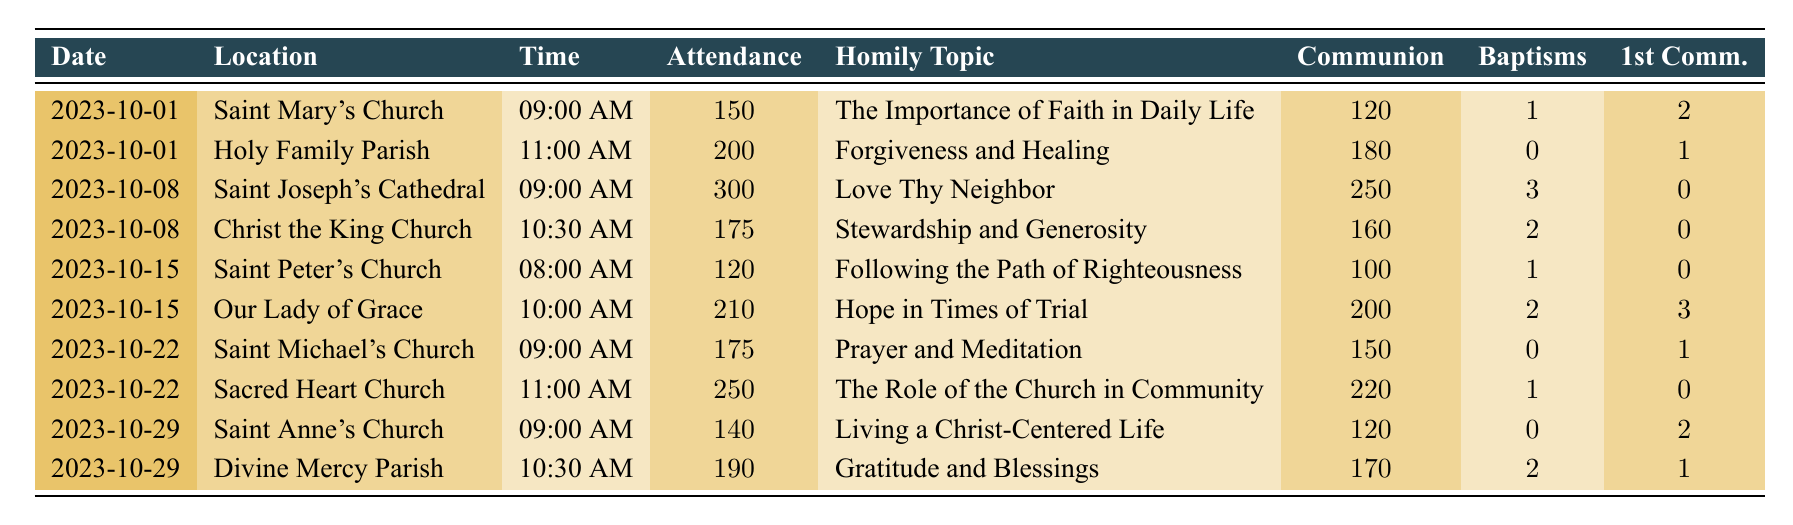What was the highest attendance recorded in a single week during October 2023? By examining the attendance column in the table, the highest attendance is found on the date 2023-10-08 at Saint Joseph's Cathedral, where 300 people attended.
Answer: 300 How many baptisms occurred across all services on October 15, 2023? Summing the baptisms from both services on that date: 1 from Saint Peter's Church and 2 from Our Lady of Grace gives a total of 1 + 2 = 3 baptisms.
Answer: 3 Which church had the topic "Hope in Times of Trial"? Looking for the specific homily topic in the table, it is found in Our Lady of Grace on October 15, 2023.
Answer: Our Lady of Grace Did any service on October 22, 2023, have more than 200 attendees? Reviewing the attendance for that date shows Sacred Heart Church had 250 attendees, so yes, it had more than 200 attendees.
Answer: Yes What is the average attendance across all services for the week of October 1, 2023? Calculate the total attendance for that week: 150 (Saint Mary's) + 200 (Holy Family) = 350. Divide by the number of services (2): 350 / 2 = 175.
Answer: 175 How many first communions were performed in total on October 29, 2023? Adding the first communions from both services on that date: 2 from Saint Anne's Church and 1 from Divine Mercy Parish gives 2 + 1 = 3 first communions.
Answer: 3 Was there a service with no baptisms in October 2023? Checking the baptisms column reveals several instances of 0 baptisms, specifically at Holy Family Parish on October 1, 2023, and at Saint Michael's Church on October 22, 2023.
Answer: Yes Which homily topic had the least number of attendees associated with it, and what was that attendance number? By comparing the attendance figures, Saint Peter's Church had the lowest attendance of 120 for the topic "Following the Path of Righteousness."
Answer: 120 How many total communions were served across all masses on October 8, 2023? Adding the number of communions served on that date gives: 250 (Saint Joseph's Cathedral) + 160 (Christ the King Church) = 410 communions.
Answer: 410 Which service on October 15, 2023, had the earliest time, and what was its attendance? The earliest service on that date was at Saint Peter's Church at 08:00 AM with an attendance of 120.
Answer: Saint Peter's Church, 120 